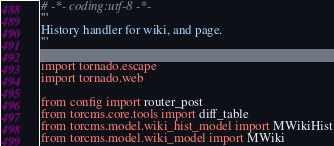<code> <loc_0><loc_0><loc_500><loc_500><_Python_># -*- coding:utf-8 -*-
'''
History handler for wiki, and page.
'''

import tornado.escape
import tornado.web

from config import router_post
from torcms.core.tools import diff_table
from torcms.model.wiki_hist_model import MWikiHist
from torcms.model.wiki_model import MWiki
</code> 